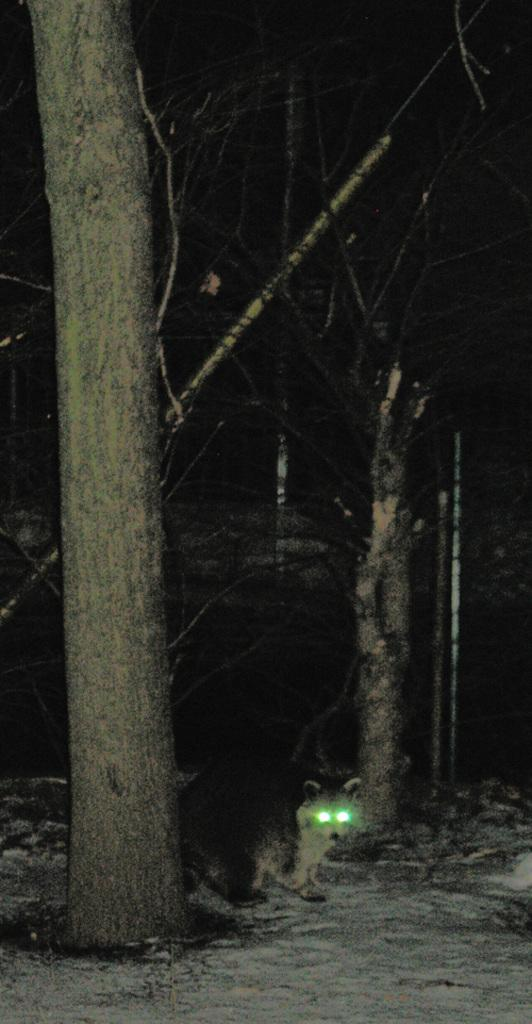What is the main subject in the center of the image? There is a tree trunk in the center of the image. What can be seen in the background of the image? There are trees in the background of the image. What type of animal is present in the image? There is an animal on the ground in the image. What hobbies does the animal in the image enjoy? There is no information about the animal's hobbies in the image, as it only shows the animal on the ground. 